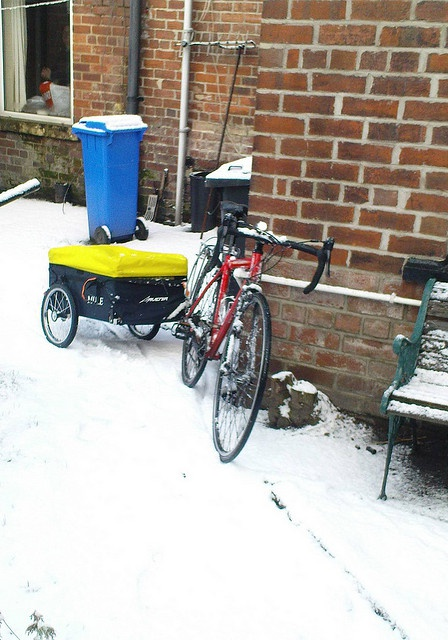Describe the objects in this image and their specific colors. I can see bicycle in ivory, gray, black, lightgray, and darkgray tones, bench in ivory, lightgray, gray, black, and teal tones, and people in ivory, black, maroon, and gray tones in this image. 